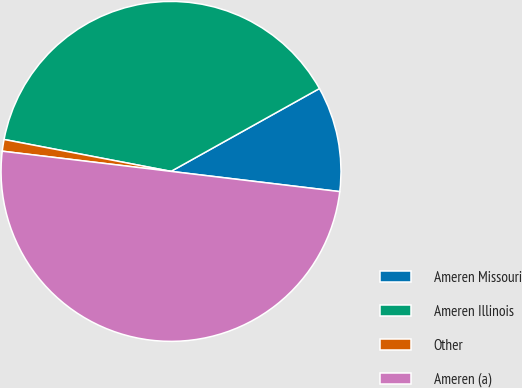Convert chart. <chart><loc_0><loc_0><loc_500><loc_500><pie_chart><fcel>Ameren Missouri<fcel>Ameren Illinois<fcel>Other<fcel>Ameren (a)<nl><fcel>10.0%<fcel>38.89%<fcel>1.11%<fcel>50.0%<nl></chart> 